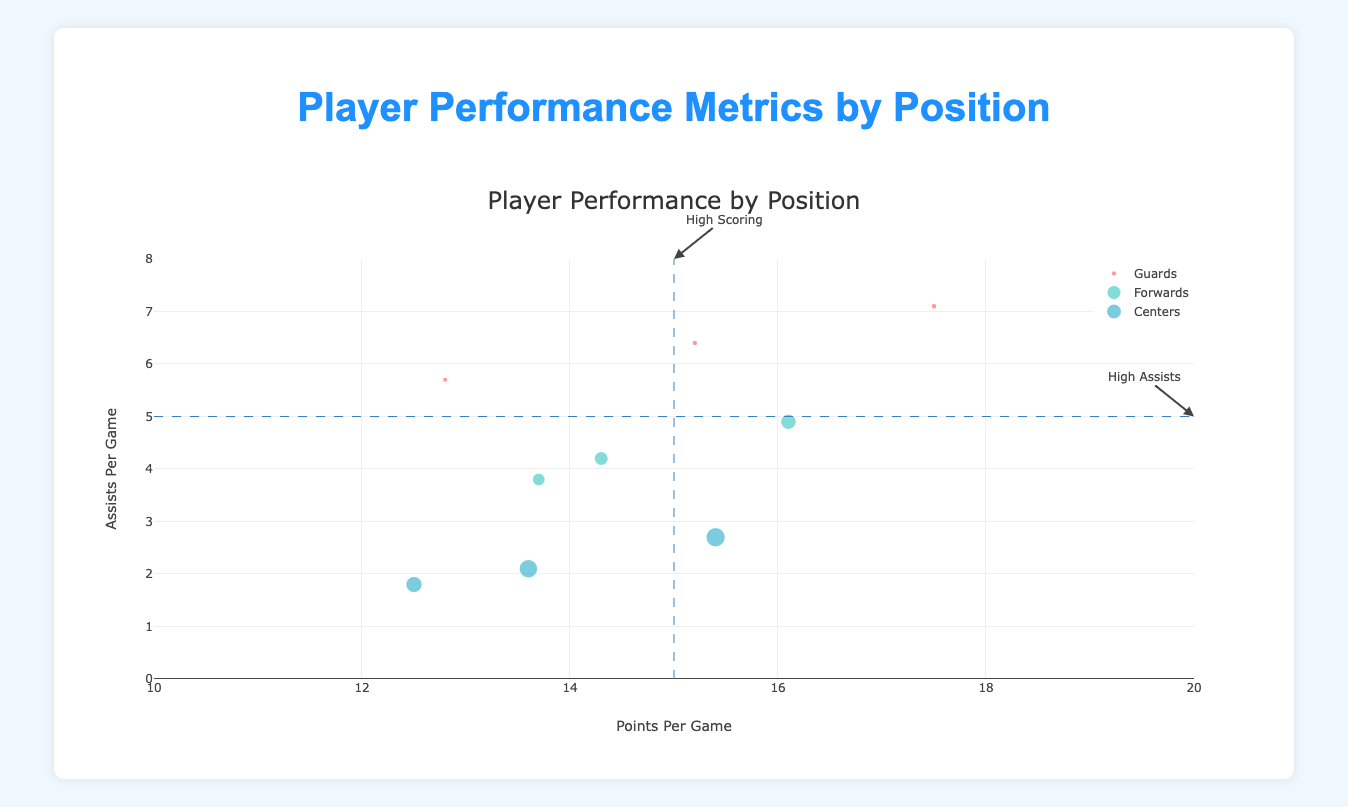Which position has the player with the highest points per game? The player with the highest points per game is found by looking for the bubble farthest right on the x-axis. Chris Evans, a Guard, has the highest points per game with 17.5
Answer: Guards Which player has the most assists per game among the centers? The player with the most assists per game among the centers is identified by finding the highest point on the y-axis within the centers' color bubbles. Samuel Harris has the most assists per game among the centers with 2.7 assists per game
Answer: Samuel Harris How many forwards have points per game over 15? Count the bubbles in the forwards' color that are positioned to the right of the x-axis value of 15. There is one bubble, Ryan White, representing a forward with points per game over 15
Answer: 1 Which position generally has higher rebounds per game? The size of the bubbles represents rebounds per game. Comparing the size within each grouped color, the centers generally have larger bubbles indicating higher rebounds per game
Answer: Centers Who is the youngest player with more than 6 assists per game? Look for the smallest y-values among the bubbles above the y-axis value of 6 and check their annotations. Mike Johnson, aged 17, has 5.7 assists per game. John Smith has 6.4 assists but is older. Chris Evans is younger but has 7.1 assists
Answer: Chris Evans Which position has the most evenly distributed assists per game? Comparing the spread of bubbles on the y-axis for all positions, the Guards show a range distribution from around 6 to 7.1 assists per game, making them more evenly distributed
Answer: Guards Which bubble correspond to the notation "High Scoring"? The horizontal annotation "High Scoring" points towards the bubbles on the x-axis at 15, indicating players with points per game around this benchmark
Answer: All players at 15 points per game What is the average points per game for the players with 3 years of experience? Add up the points per game of players with 3 years of experience (15.2, 14.3, 13.6), which totals to 43.1, and divide by the number of such players, which is 3. The average is 14.37
Answer: 14.37 Who is the player with the highest assists per game among the guards, and how many assists does he have? Find the highest point on the y-axis among the guards' color bubbles and read the annotation. Chris Evans has the highest assists per game among the guards with 7.1
Answer: Chris Evans, 7.1 Which position has the player with the lowest rebounds per game and who is that player? Identify the smallest bubble across all positions to find the player with the lowest rebounds per game, which is Mike Johnson among the guards with 2.9 rebounds per game
Answer: Guards, Mike Johnson 